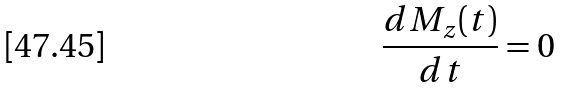<formula> <loc_0><loc_0><loc_500><loc_500>\frac { d M _ { z } ( t ) } { d t } = 0</formula> 